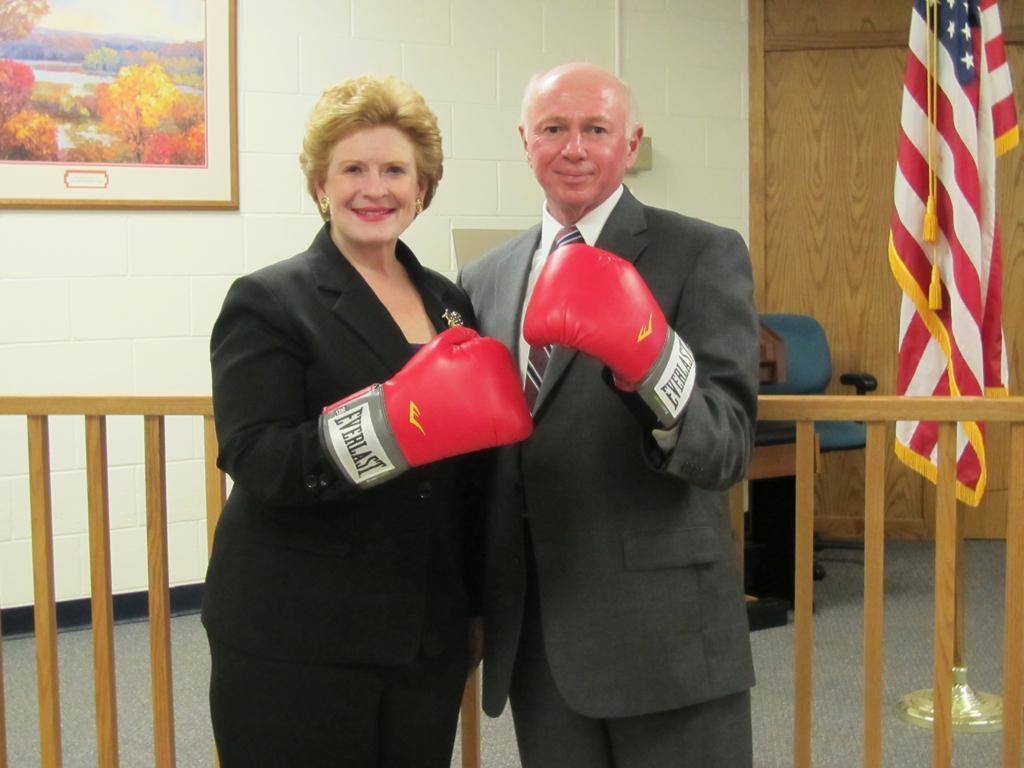Can you describe this image briefly? In the center of the image we can see a man and a lady standing. They are wearing boxing gloves to their hands. In the background there is a fence, wall, door, chair, flag and a wall frame placed on the wall. 